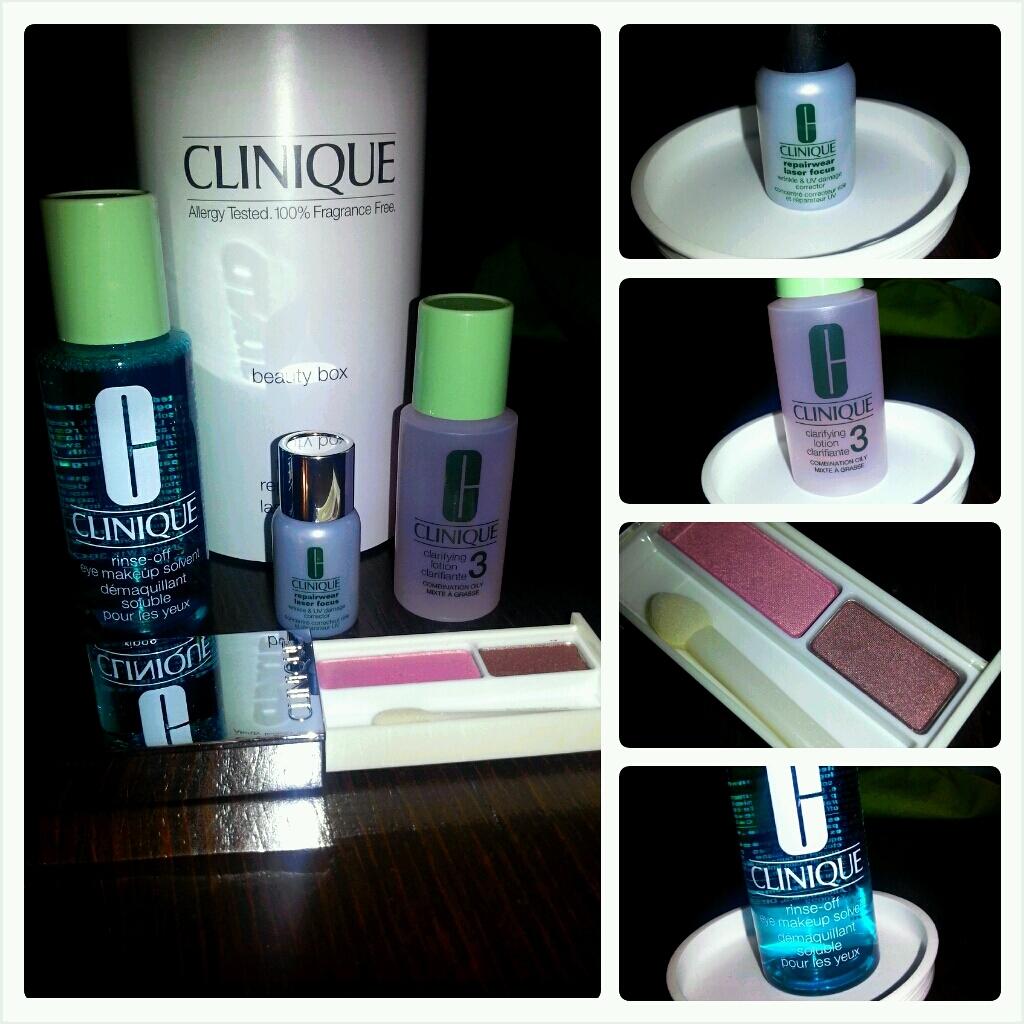What is the big bottle 100% free of?
Ensure brevity in your answer.  Fragrance. 